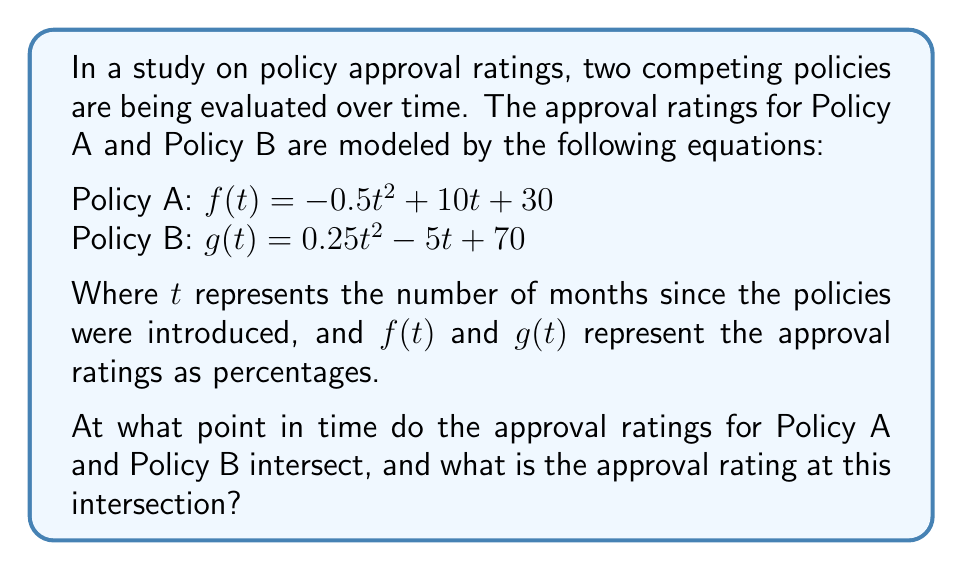Can you solve this math problem? To find the intersection point of the two policy approval rating curves, we need to solve the equation $f(t) = g(t)$. This will give us the time $t$ when the approval ratings are equal.

1) Set up the equation:
   $-0.5t^2 + 10t + 30 = 0.25t^2 - 5t + 70$

2) Rearrange the equation to standard form:
   $-0.5t^2 + 10t + 30 = 0.25t^2 - 5t + 70$
   $-0.75t^2 + 15t - 40 = 0$

3) Multiply all terms by -4 to simplify the coefficients:
   $3t^2 - 60t + 160 = 0$

4) This is a quadratic equation in the form $at^2 + bt + c = 0$, where:
   $a = 3$, $b = -60$, and $c = 160$

5) Use the quadratic formula: $t = \frac{-b \pm \sqrt{b^2 - 4ac}}{2a}$

6) Substitute the values:
   $t = \frac{60 \pm \sqrt{(-60)^2 - 4(3)(160)}}{2(3)}$
   $t = \frac{60 \pm \sqrt{3600 - 1920}}{6}$
   $t = \frac{60 \pm \sqrt{1680}}{6}$
   $t = \frac{60 \pm 40.99}{6}$

7) This gives us two solutions:
   $t_1 = \frac{60 + 40.99}{6} \approx 16.83$
   $t_2 = \frac{60 - 40.99}{6} \approx 3.17$

8) Since time cannot be negative in this context, we'll use $t \approx 3.17$ months.

9) To find the approval rating at this intersection, we can substitute this t-value into either $f(t)$ or $g(t)$:

   $f(3.17) = -0.5(3.17)^2 + 10(3.17) + 30$
            $\approx -5.02 + 31.7 + 30$
            $\approx 56.68$

Therefore, the approval ratings intersect after approximately 3.17 months at about 56.68%.
Answer: The approval ratings for Policy A and Policy B intersect after approximately 3.17 months, with an approval rating of about 56.68%. 